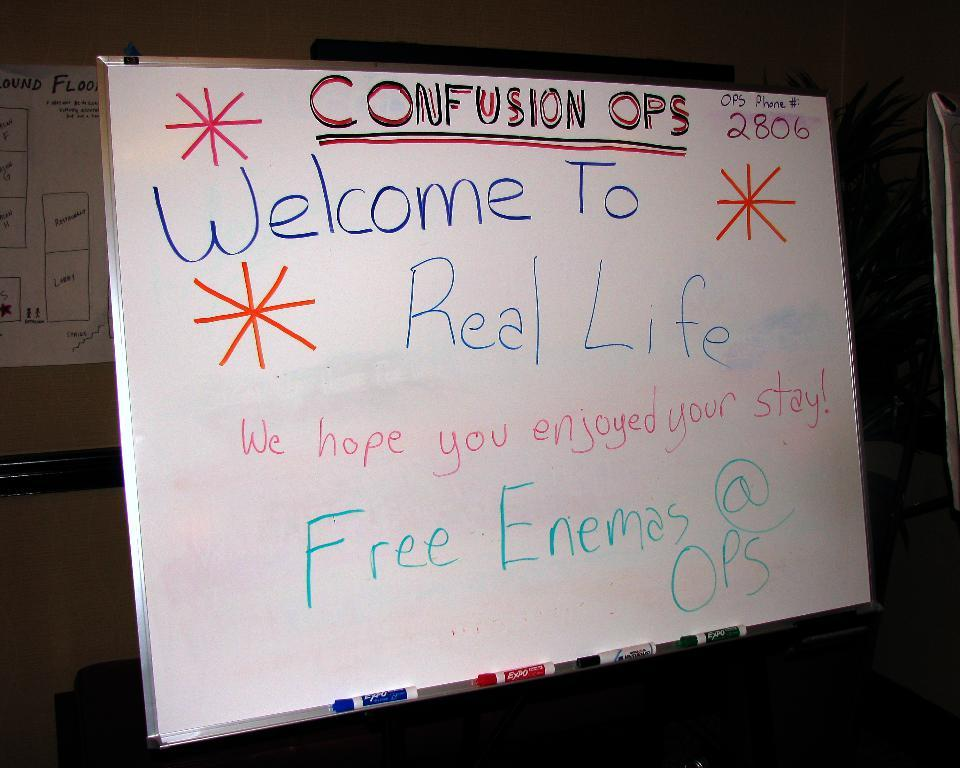<image>
Provide a brief description of the given image. A whiteboard says "Confusion Ops Welcome To Real Life." 